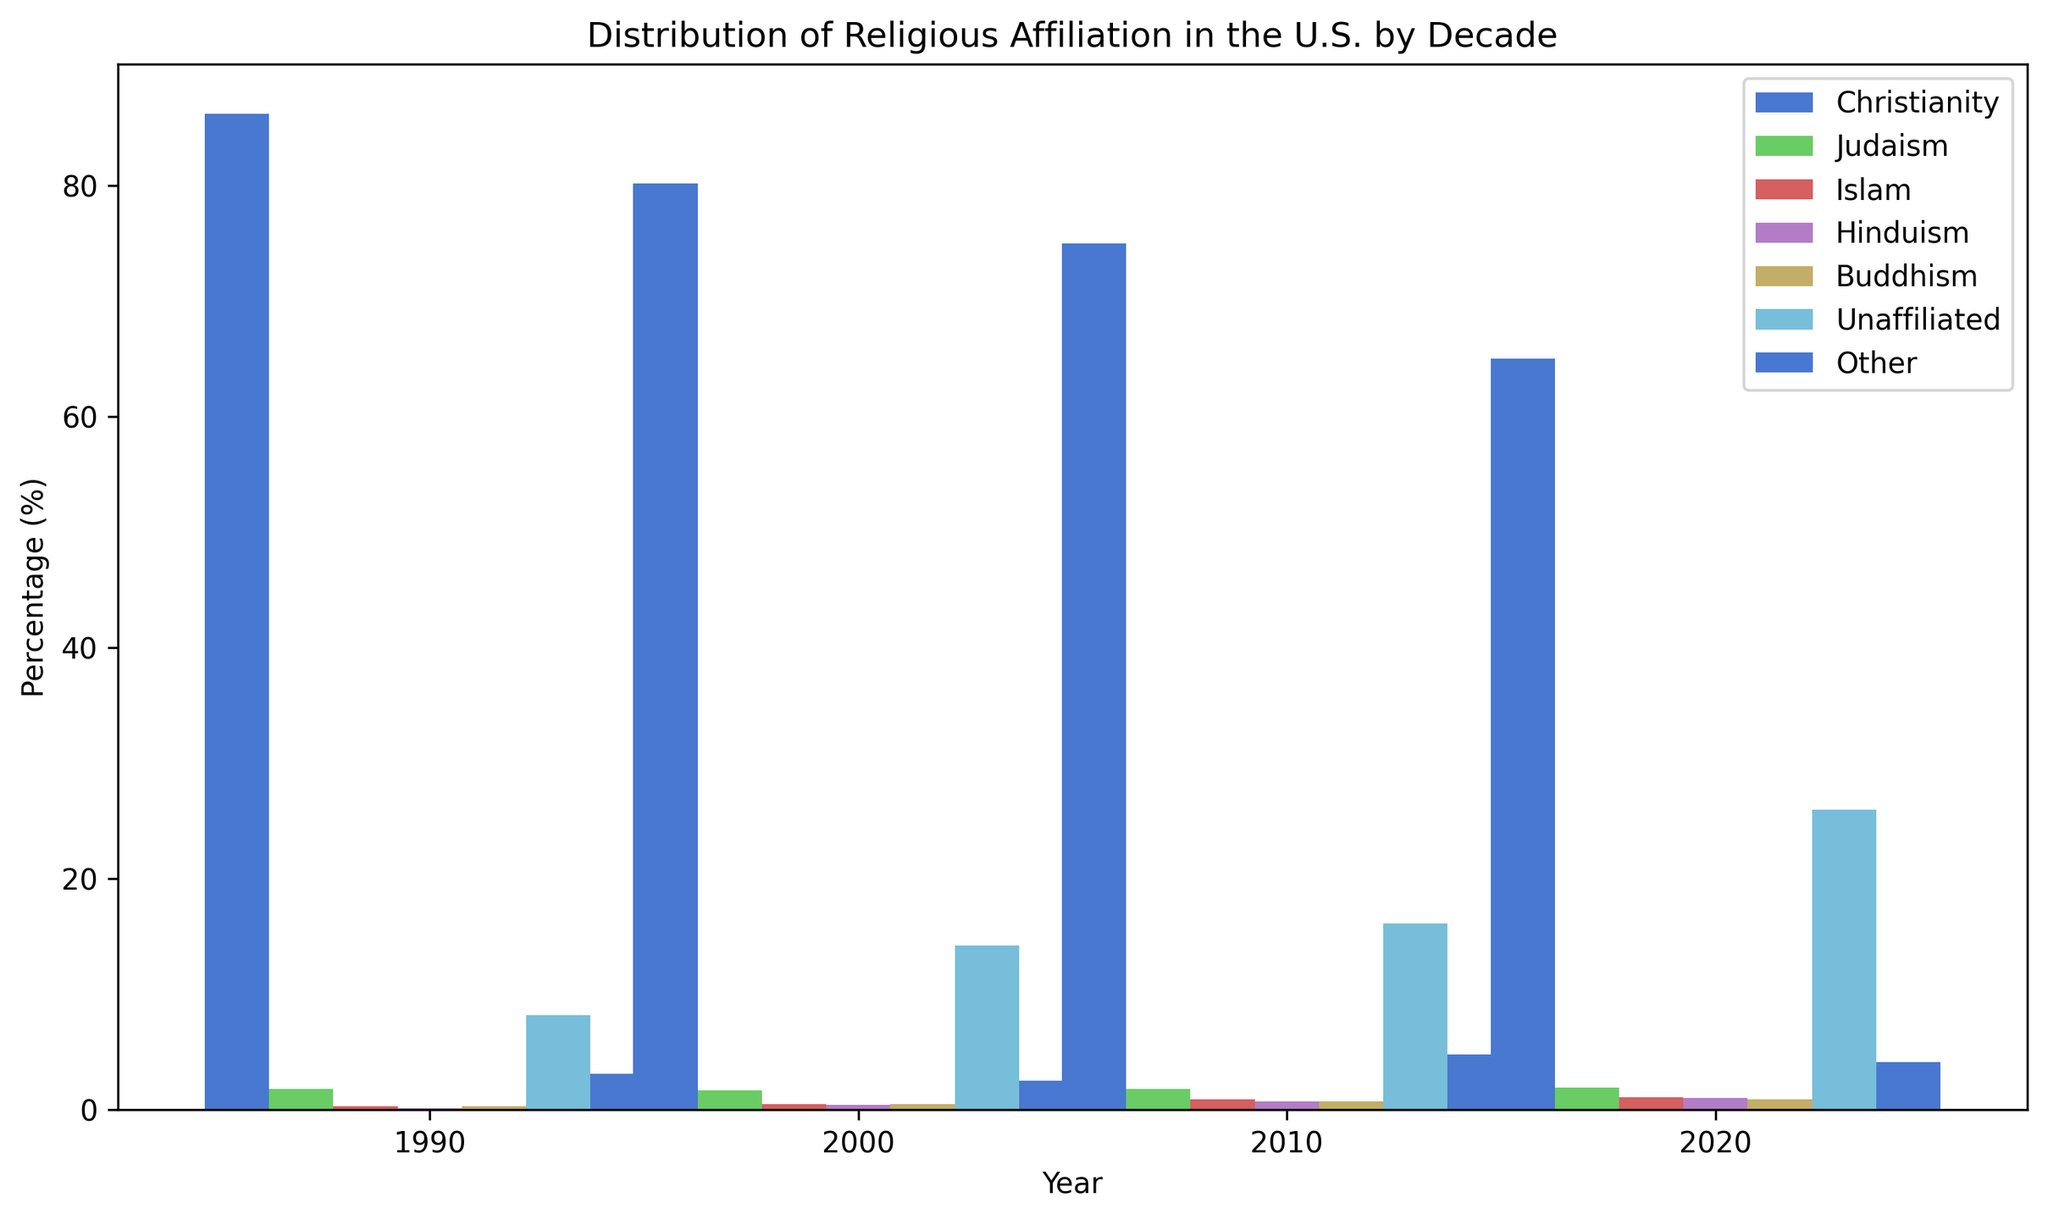Which religious affiliation had the highest percentage in 2020? We look at the bars for the year 2020 and find the tallest one. The tallest bar is for "Christianity" although "Unaffiliated" also has similar sizeable height. Upon closer inspection of the y-axis, "Christianity" has surpassed "Unaffiliated".
Answer: Christianity By how much did the percentage of "Unaffiliated" increase from 2000 to 2020? We compare the height of the "Unaffiliated" bar in 2000 with its height in 2020. In 2000, it is at 14.2%, and in 2020, it is at 26.0%. We then subtract 14.2% from 26.0%.
Answer: 11.8% Which religion showed the largest proportional increase from 1990 to 2020? To find the largest proportional increase, we look at the percentage increase for each religion from 1990 to 2020. We calculate the increase for each religion as (value in 2020 - value in 1990) / value in 1990. The religion that shows the highest result from this calculation will be the one with the largest proportional increase.
Answer: Islam In 2020, how does the percentage of "Judaism" compare to that of "Islam"? We observe the bars for "Judaism" and "Islam" in 2020. The bar for "Judaism" reaches 1.9%, while the bar for "Islam" reaches 1.1%. Comparing these values, we see that "Judaism" is higher than "Islam".
Answer: Judaism is higher than Islam What is the average percentage of "Christianity" over the four decades? We sum up the value of "Christianity" across all four decades (86.2 + 80.2 + 75.0 + 65.0) and then divide by 4. This gives the average percentage.
Answer: 76.6% How did the percentage of "Other" change from 1990 to 2020? We check the percentages for "Other" in 1990 and 2020. In 1990, it is 3.1%, and in 2020, it is 4.1%. We subtract 3.1% from 4.1% to find the increment.
Answer: 1% What trend is depicted by the "Christianity" percentage over the decades? We observe the bars for "Christianity" from 1990 to 2020. The bar gradually decreases over these years. This suggests that the percentage of "Christianity" is declining over the decades.
Answer: Declining Which two religious affiliations had a continuous increase over the four decades? We need to identify affiliations whose bars increase from 1990 to 2000, 2000 to 2010, and 2010 to 2020. We find that "Islam" and "Unaffiliated" have steadily increasing percentages throughout these years.
Answer: Islam and Unaffiliated 